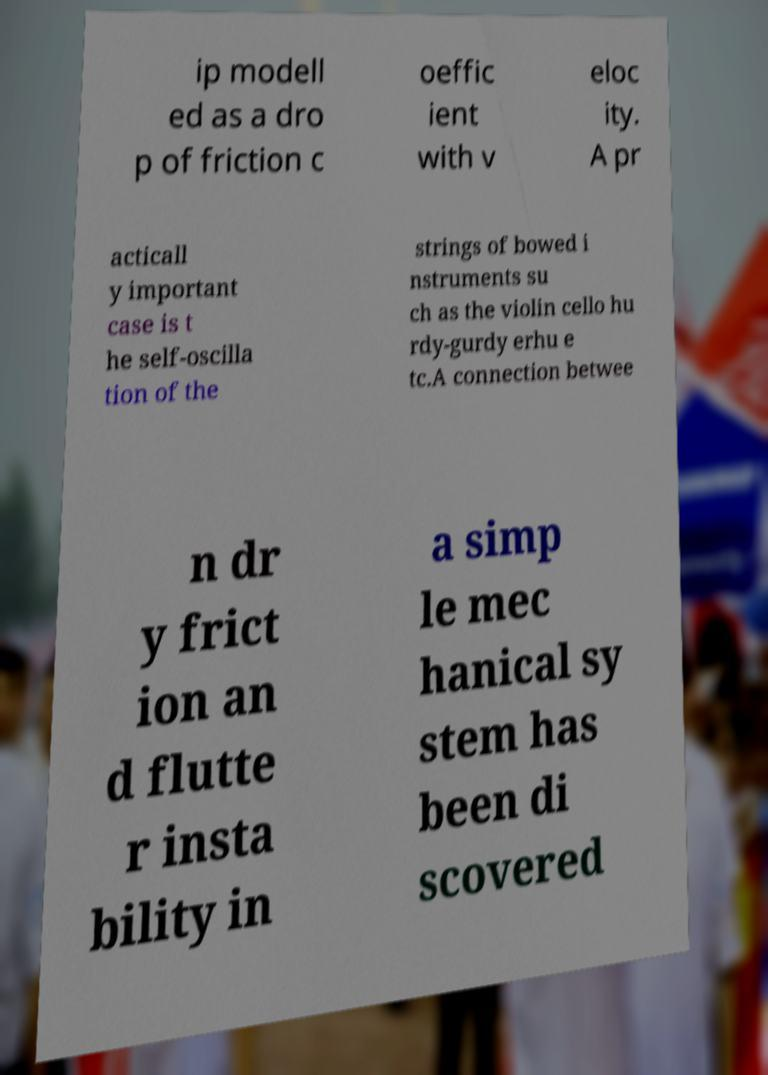Can you accurately transcribe the text from the provided image for me? ip modell ed as a dro p of friction c oeffic ient with v eloc ity. A pr acticall y important case is t he self-oscilla tion of the strings of bowed i nstruments su ch as the violin cello hu rdy-gurdy erhu e tc.A connection betwee n dr y frict ion an d flutte r insta bility in a simp le mec hanical sy stem has been di scovered 